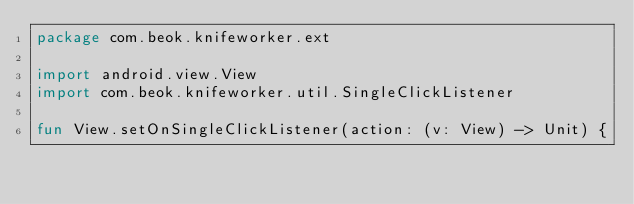<code> <loc_0><loc_0><loc_500><loc_500><_Kotlin_>package com.beok.knifeworker.ext

import android.view.View
import com.beok.knifeworker.util.SingleClickListener

fun View.setOnSingleClickListener(action: (v: View) -> Unit) {</code> 